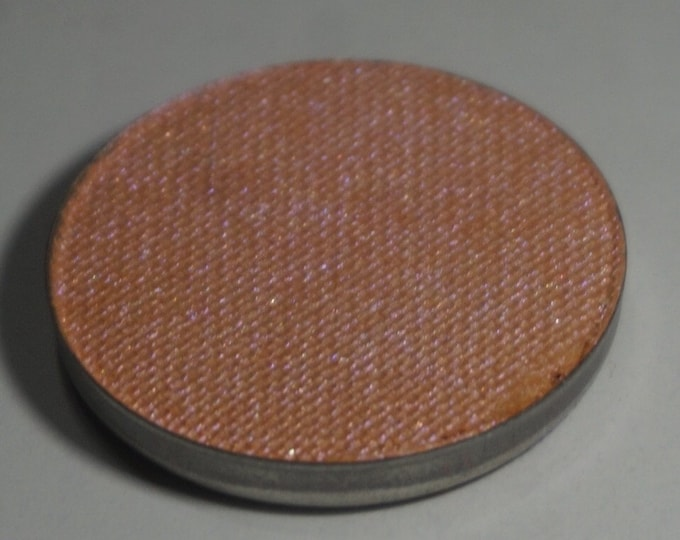What could be some alternative uses for this disc if it isn’t part of an acoustic device? While the disc appears to be suited for an acoustic setup, it could also have other uses. For instance, it might function as a heat diffuser in devices that dissipate excess heat. The fabric texture could provide a cushioned surface, suggesting potential use as a soft footpad or coaster. The aesthetic quality might even lend it to usage as an ornamental piece in artistic or interior design projects, possibly even as a unique type of fabric sharegpt4v/sample or material swatch for upholstery. How could the material choice affect other potential uses? The material choice significantly impacts the versatility and functionality of the disc. If the fabric is fire-retardant, it could safely be used in environments where heat resistance is essential, such as in a kitchen setting as a trivet or pot holder. If it has antimicrobial properties, it might serve well in applications requiring hygiene control, like a protective cover for medical instruments. Material durability plays a role too; a more robust material could make it suitable for industrial applications as a protective cover or padding, whereas a more delicate fabric might be suited for decorative purposes. 